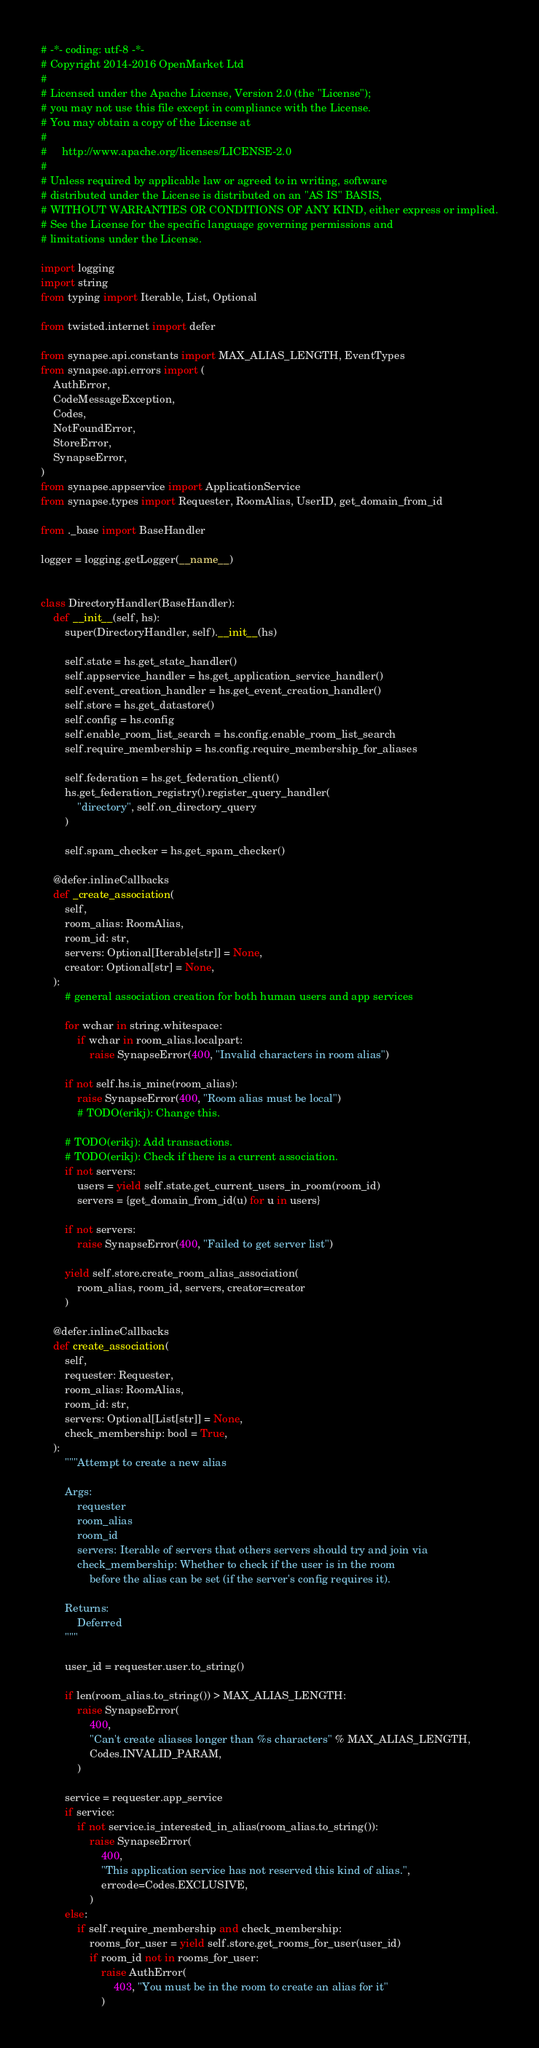Convert code to text. <code><loc_0><loc_0><loc_500><loc_500><_Python_># -*- coding: utf-8 -*-
# Copyright 2014-2016 OpenMarket Ltd
#
# Licensed under the Apache License, Version 2.0 (the "License");
# you may not use this file except in compliance with the License.
# You may obtain a copy of the License at
#
#     http://www.apache.org/licenses/LICENSE-2.0
#
# Unless required by applicable law or agreed to in writing, software
# distributed under the License is distributed on an "AS IS" BASIS,
# WITHOUT WARRANTIES OR CONDITIONS OF ANY KIND, either express or implied.
# See the License for the specific language governing permissions and
# limitations under the License.

import logging
import string
from typing import Iterable, List, Optional

from twisted.internet import defer

from synapse.api.constants import MAX_ALIAS_LENGTH, EventTypes
from synapse.api.errors import (
    AuthError,
    CodeMessageException,
    Codes,
    NotFoundError,
    StoreError,
    SynapseError,
)
from synapse.appservice import ApplicationService
from synapse.types import Requester, RoomAlias, UserID, get_domain_from_id

from ._base import BaseHandler

logger = logging.getLogger(__name__)


class DirectoryHandler(BaseHandler):
    def __init__(self, hs):
        super(DirectoryHandler, self).__init__(hs)

        self.state = hs.get_state_handler()
        self.appservice_handler = hs.get_application_service_handler()
        self.event_creation_handler = hs.get_event_creation_handler()
        self.store = hs.get_datastore()
        self.config = hs.config
        self.enable_room_list_search = hs.config.enable_room_list_search
        self.require_membership = hs.config.require_membership_for_aliases

        self.federation = hs.get_federation_client()
        hs.get_federation_registry().register_query_handler(
            "directory", self.on_directory_query
        )

        self.spam_checker = hs.get_spam_checker()

    @defer.inlineCallbacks
    def _create_association(
        self,
        room_alias: RoomAlias,
        room_id: str,
        servers: Optional[Iterable[str]] = None,
        creator: Optional[str] = None,
    ):
        # general association creation for both human users and app services

        for wchar in string.whitespace:
            if wchar in room_alias.localpart:
                raise SynapseError(400, "Invalid characters in room alias")

        if not self.hs.is_mine(room_alias):
            raise SynapseError(400, "Room alias must be local")
            # TODO(erikj): Change this.

        # TODO(erikj): Add transactions.
        # TODO(erikj): Check if there is a current association.
        if not servers:
            users = yield self.state.get_current_users_in_room(room_id)
            servers = {get_domain_from_id(u) for u in users}

        if not servers:
            raise SynapseError(400, "Failed to get server list")

        yield self.store.create_room_alias_association(
            room_alias, room_id, servers, creator=creator
        )

    @defer.inlineCallbacks
    def create_association(
        self,
        requester: Requester,
        room_alias: RoomAlias,
        room_id: str,
        servers: Optional[List[str]] = None,
        check_membership: bool = True,
    ):
        """Attempt to create a new alias

        Args:
            requester
            room_alias
            room_id
            servers: Iterable of servers that others servers should try and join via
            check_membership: Whether to check if the user is in the room
                before the alias can be set (if the server's config requires it).

        Returns:
            Deferred
        """

        user_id = requester.user.to_string()

        if len(room_alias.to_string()) > MAX_ALIAS_LENGTH:
            raise SynapseError(
                400,
                "Can't create aliases longer than %s characters" % MAX_ALIAS_LENGTH,
                Codes.INVALID_PARAM,
            )

        service = requester.app_service
        if service:
            if not service.is_interested_in_alias(room_alias.to_string()):
                raise SynapseError(
                    400,
                    "This application service has not reserved this kind of alias.",
                    errcode=Codes.EXCLUSIVE,
                )
        else:
            if self.require_membership and check_membership:
                rooms_for_user = yield self.store.get_rooms_for_user(user_id)
                if room_id not in rooms_for_user:
                    raise AuthError(
                        403, "You must be in the room to create an alias for it"
                    )
</code> 